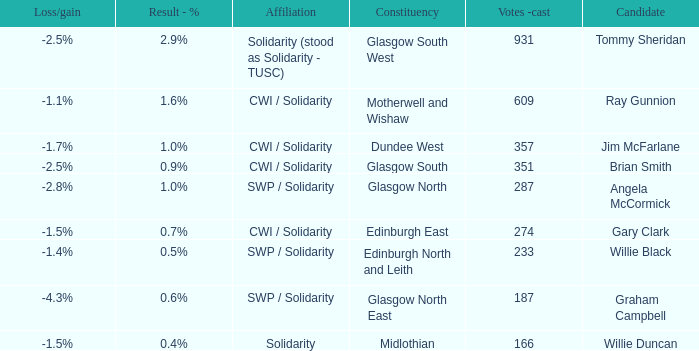How many votes were cast when the constituency was midlothian? 166.0. 